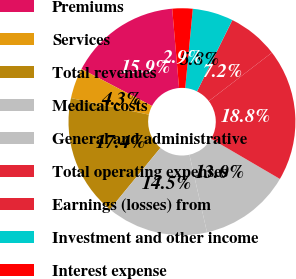Convert chart. <chart><loc_0><loc_0><loc_500><loc_500><pie_chart><fcel>Premiums<fcel>Services<fcel>Total revenues<fcel>Medical costs<fcel>General and administrative<fcel>Total operating expenses<fcel>Earnings (losses) from<fcel>Investment and other income<fcel>Interest expense<nl><fcel>15.94%<fcel>4.35%<fcel>17.39%<fcel>14.49%<fcel>13.04%<fcel>18.84%<fcel>7.25%<fcel>5.8%<fcel>2.9%<nl></chart> 